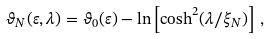Convert formula to latex. <formula><loc_0><loc_0><loc_500><loc_500>\vartheta _ { N } ( \varepsilon , \lambda ) = \vartheta _ { 0 } ( \varepsilon ) - \ln \left [ \cosh ^ { 2 } ( \lambda / \xi _ { N } ) \right ] \, ,</formula> 